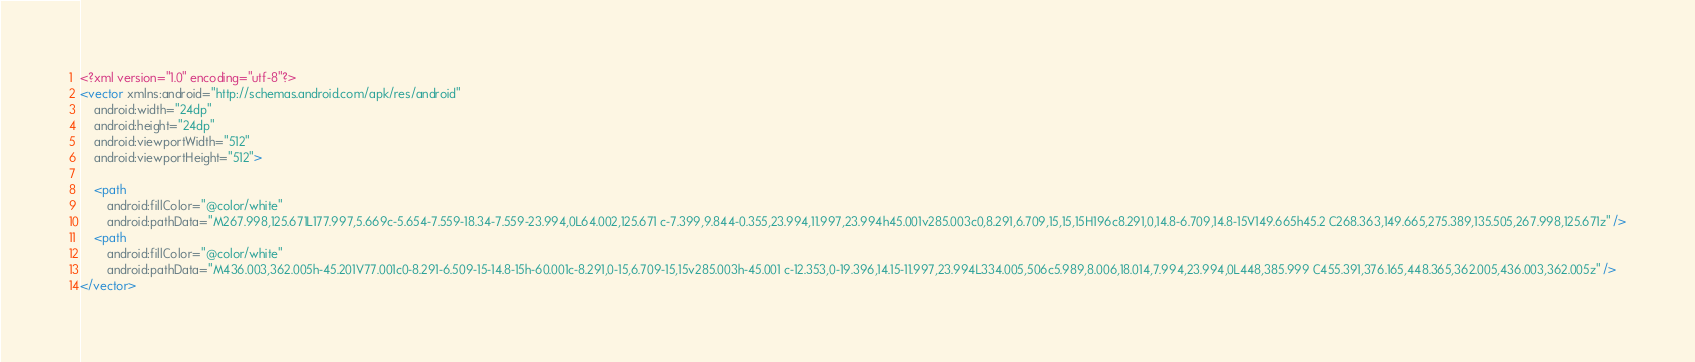Convert code to text. <code><loc_0><loc_0><loc_500><loc_500><_XML_><?xml version="1.0" encoding="utf-8"?>
<vector xmlns:android="http://schemas.android.com/apk/res/android"
    android:width="24dp"
    android:height="24dp"
    android:viewportWidth="512"
    android:viewportHeight="512">

    <path
        android:fillColor="@color/white"
        android:pathData="M267.998,125.671L177.997,5.669c-5.654-7.559-18.34-7.559-23.994,0L64.002,125.671 c-7.399,9.844-0.355,23.994,11.997,23.994h45.001v285.003c0,8.291,6.709,15,15,15H196c8.291,0,14.8-6.709,14.8-15V149.665h45.2 C268.363,149.665,275.389,135.505,267.998,125.671z" />
    <path
        android:fillColor="@color/white"
        android:pathData="M436.003,362.005h-45.201V77.001c0-8.291-6.509-15-14.8-15h-60.001c-8.291,0-15,6.709-15,15v285.003h-45.001 c-12.353,0-19.396,14.15-11.997,23.994L334.005,506c5.989,8.006,18.014,7.994,23.994,0L448,385.999 C455.391,376.165,448.365,362.005,436.003,362.005z" />
</vector></code> 